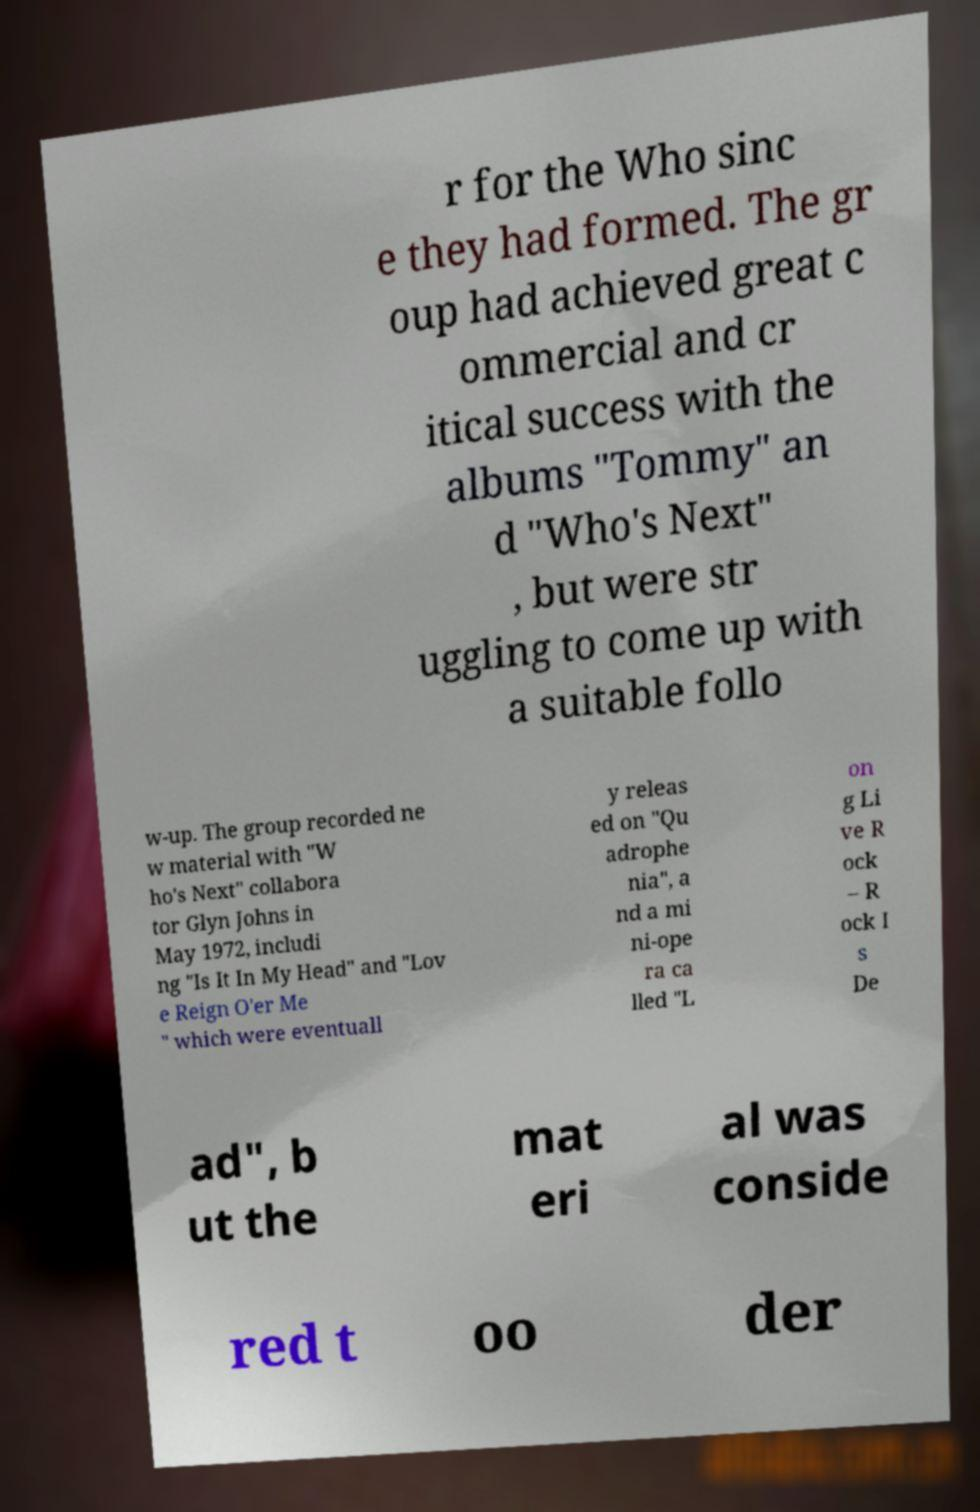For documentation purposes, I need the text within this image transcribed. Could you provide that? r for the Who sinc e they had formed. The gr oup had achieved great c ommercial and cr itical success with the albums "Tommy" an d "Who's Next" , but were str uggling to come up with a suitable follo w-up. The group recorded ne w material with "W ho's Next" collabora tor Glyn Johns in May 1972, includi ng "Is It In My Head" and "Lov e Reign O'er Me " which were eventuall y releas ed on "Qu adrophe nia", a nd a mi ni-ope ra ca lled "L on g Li ve R ock – R ock I s De ad", b ut the mat eri al was conside red t oo der 